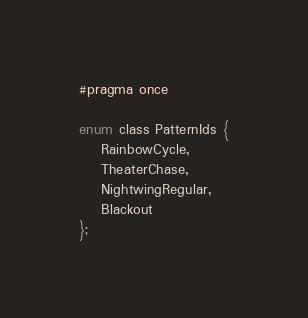<code> <loc_0><loc_0><loc_500><loc_500><_C_>#pragma once

enum class PatternIds {
	RainbowCycle,
	TheaterChase,
	NightwingRegular,
	Blackout
};</code> 